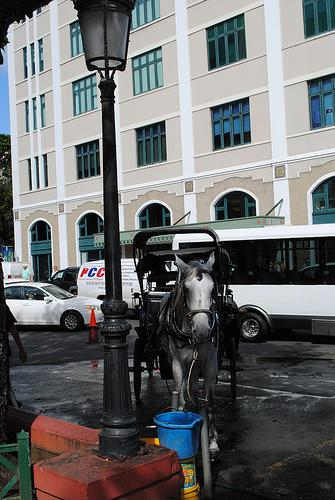Question: where was this photo taken?
Choices:
A. An intersection.
B. Street corner.
C. A city street.
D. The sidewalk.
Answer with the letter. Answer: B Question: what animal is in the photo?
Choices:
A. Gorilla.
B. Antelope.
C. Horse.
D. Cow.
Answer with the letter. Answer: C Question: why is the horse harnessed?
Choices:
A. Being led in parade.
B. To pull the carriage.
C. In a rodeo.
D. Going to the veterinarian.
Answer with the letter. Answer: B Question: how is the weather in the photo?
Choices:
A. Rainy.
B. Windy.
C. Snowing.
D. Sunny.
Answer with the letter. Answer: D 